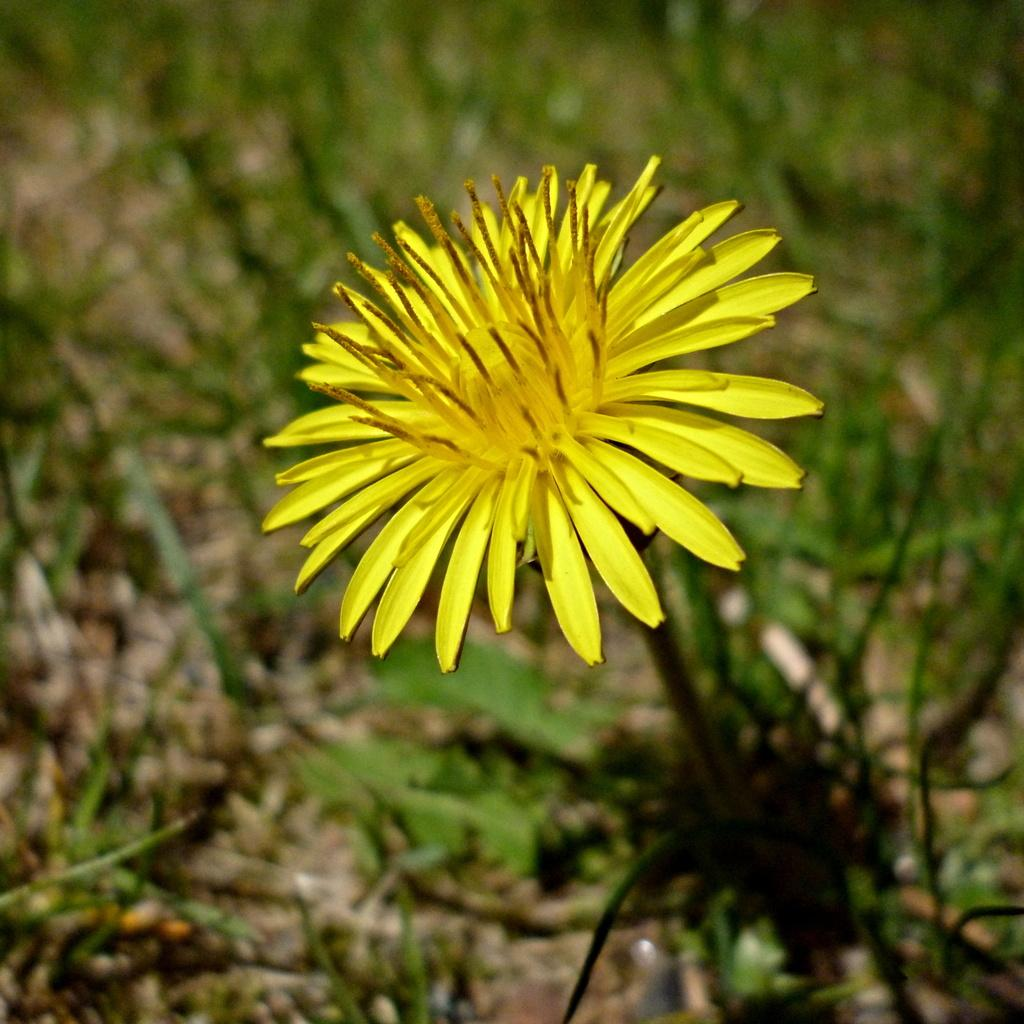What type of flower is in the picture? There is a yellow flower in the picture. How would you describe the background of the picture? The background of the picture is blurred. What other plants can be seen in the background? There are green plants visible in the background. What type of straw is being used to play the songs in the picture? There is no straw or any indication of songs being played in the picture; it features a yellow flower and blurred background with green plants. 